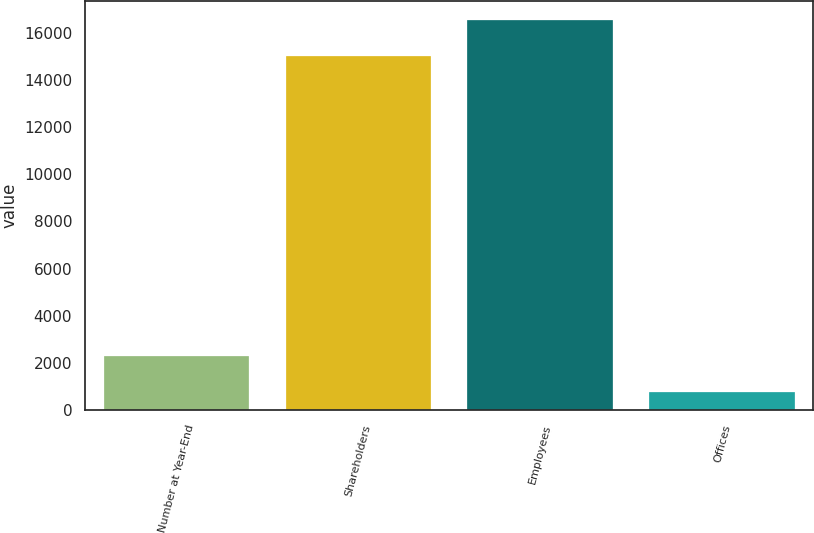<chart> <loc_0><loc_0><loc_500><loc_500><bar_chart><fcel>Number at Year-End<fcel>Shareholders<fcel>Employees<fcel>Offices<nl><fcel>2305.7<fcel>15015<fcel>16524.7<fcel>796<nl></chart> 